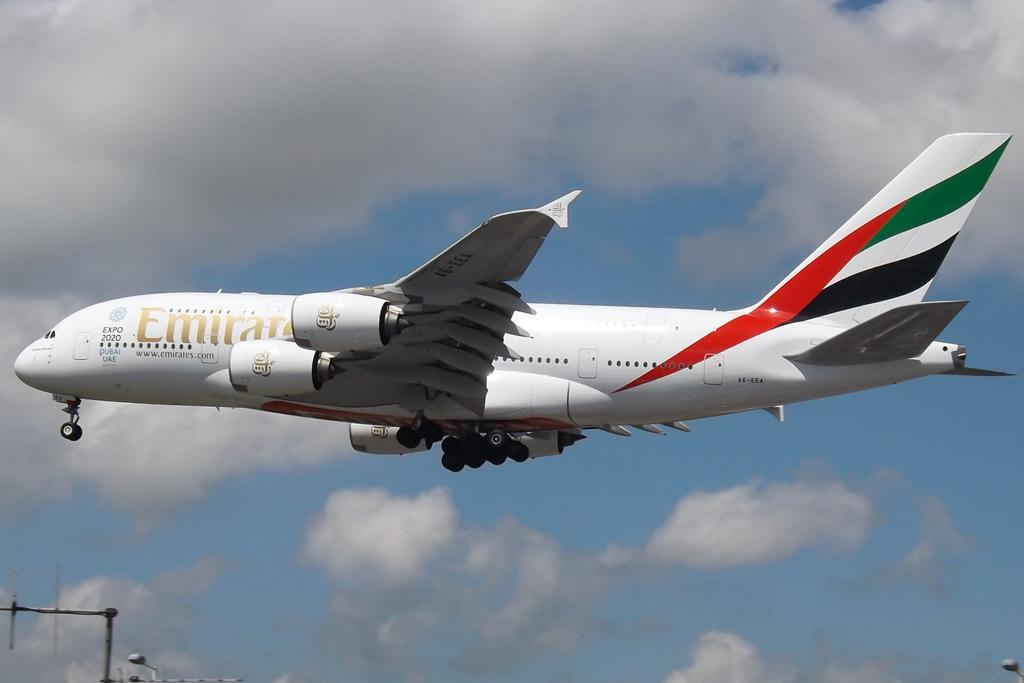<image>
Summarize the visual content of the image. A Emirates plane flying in the sky with clouds 